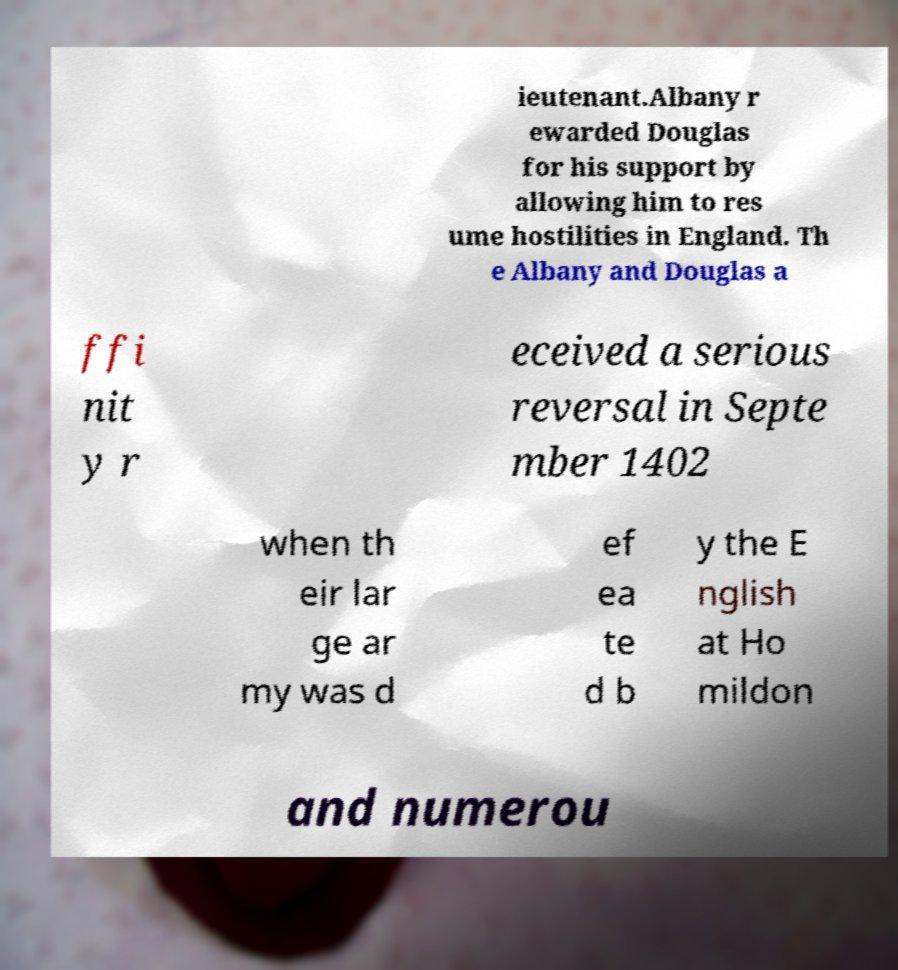Could you extract and type out the text from this image? ieutenant.Albany r ewarded Douglas for his support by allowing him to res ume hostilities in England. Th e Albany and Douglas a ffi nit y r eceived a serious reversal in Septe mber 1402 when th eir lar ge ar my was d ef ea te d b y the E nglish at Ho mildon and numerou 